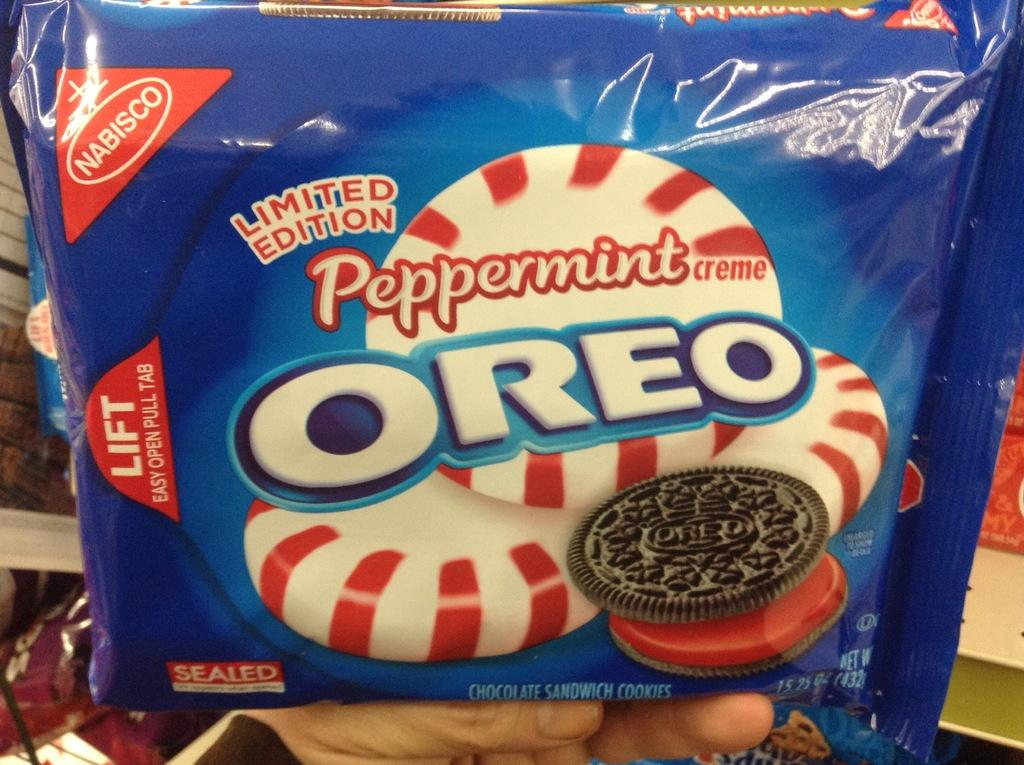What can be seen in the image that belongs to a person? There is a person's hand in the image. What object is present in the image that might be related to food? There is a food packet in the image. What is depicted on the food packet? The food packet has a picture of a biscuit. What information is provided on the food packet? There is text on the food packet. Are there any giants visible in the image? No, there are no giants present in the image. What type of toys can be seen in the image? There are no toys present in the image. 